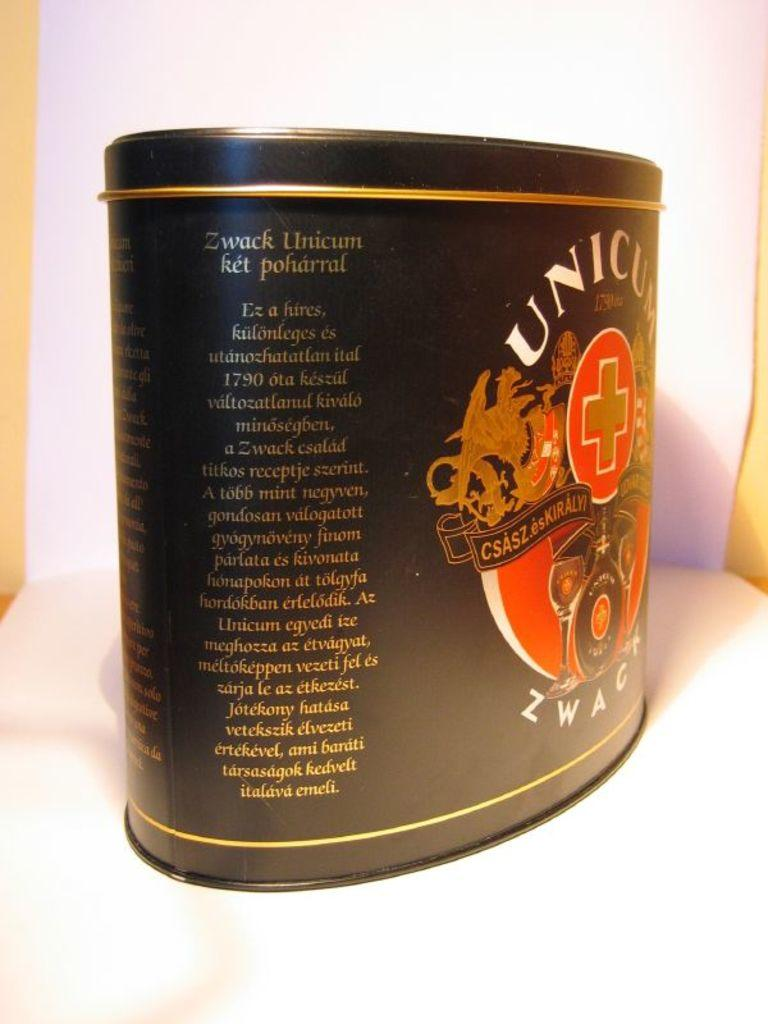<image>
Summarize the visual content of the image. Some sort of a product in a tin called Zwack Unicorn. 